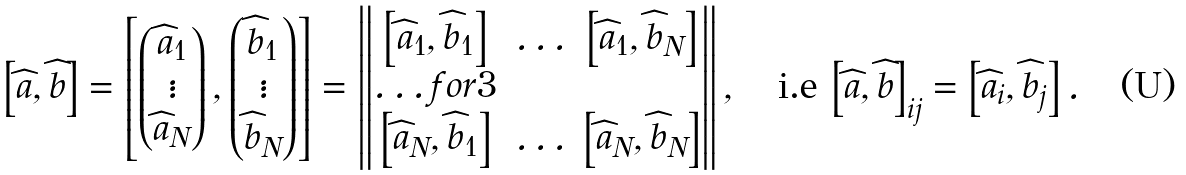<formula> <loc_0><loc_0><loc_500><loc_500>\left [ \widehat { a } , \widehat { b } \right ] = \left [ \begin{pmatrix} \widehat { a } _ { 1 } \\ \vdots \\ \widehat { a } _ { N } \end{pmatrix} , \begin{pmatrix} \widehat { b } _ { 1 } \\ \vdots \\ \widehat { b } _ { N } \end{pmatrix} \right ] = \begin{Vmatrix} \left [ \widehat { a } _ { 1 } , \widehat { b } _ { 1 } \right ] & \hdots & \left [ \widehat { a } _ { 1 } , \widehat { b } _ { N } \right ] \\ \hdots f o r { 3 } \\ \left [ \widehat { a } _ { N } , \widehat { b } _ { 1 } \right ] & \hdots & \left [ \widehat { a } _ { N } , \widehat { b } _ { N } \right ] \end{Vmatrix} , \quad \text {i.e} \ { \left [ \widehat { a } , \widehat { b } \right ] } _ { i j } = \left [ \widehat { a } _ { i } , \widehat { b } _ { j } \right ] .</formula> 